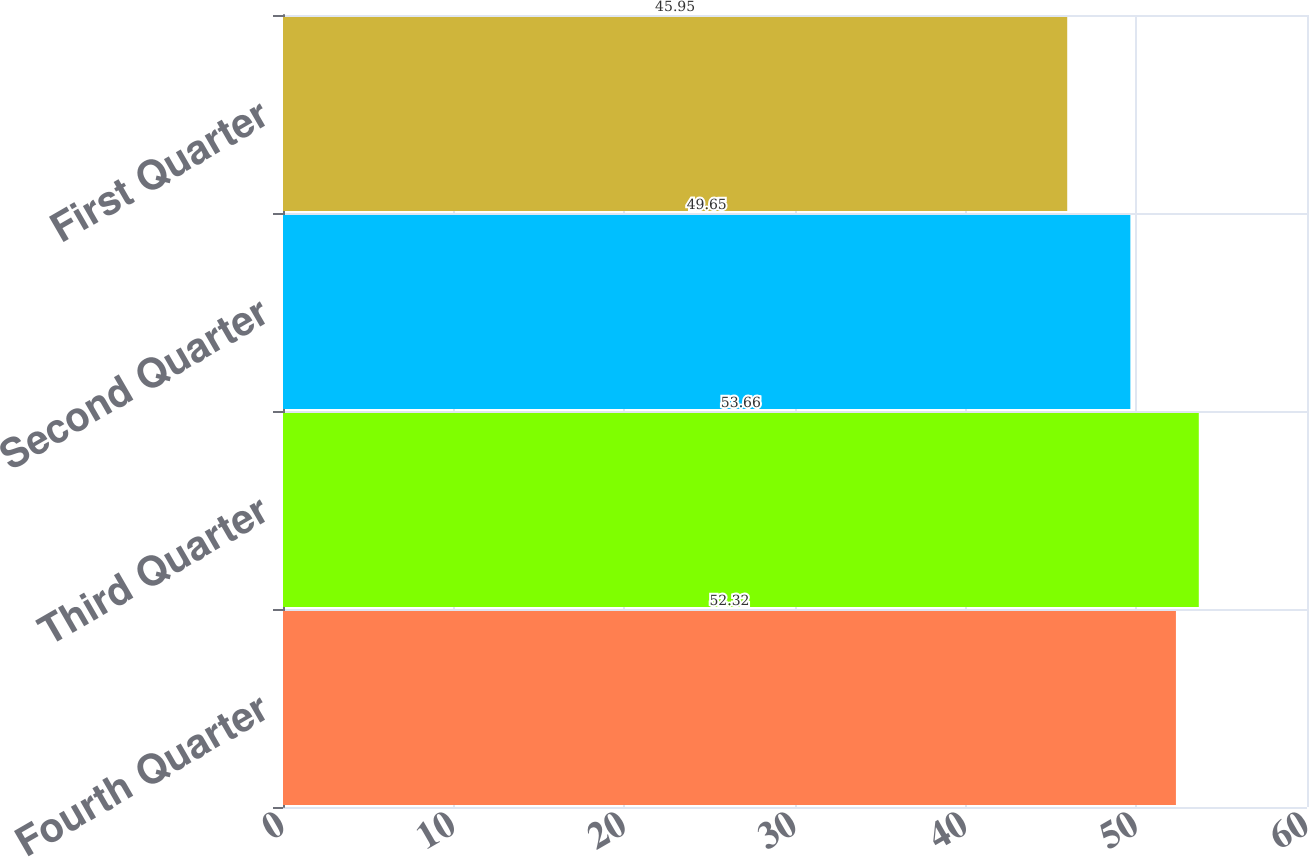Convert chart. <chart><loc_0><loc_0><loc_500><loc_500><bar_chart><fcel>Fourth Quarter<fcel>Third Quarter<fcel>Second Quarter<fcel>First Quarter<nl><fcel>52.32<fcel>53.66<fcel>49.65<fcel>45.95<nl></chart> 